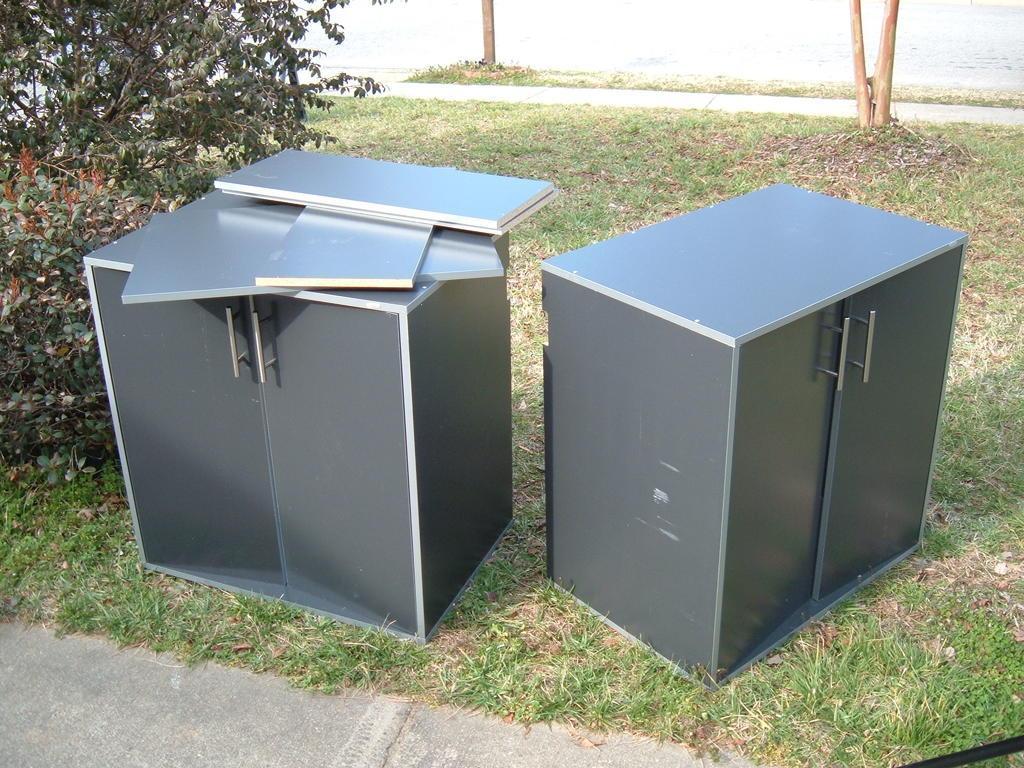Please provide a concise description of this image. In this image we can see two small wardrobes on the grass. We can also see the trees and also path. 